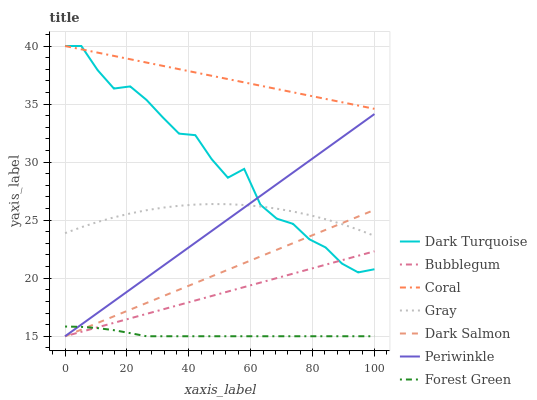Does Forest Green have the minimum area under the curve?
Answer yes or no. Yes. Does Coral have the maximum area under the curve?
Answer yes or no. Yes. Does Dark Turquoise have the minimum area under the curve?
Answer yes or no. No. Does Dark Turquoise have the maximum area under the curve?
Answer yes or no. No. Is Dark Salmon the smoothest?
Answer yes or no. Yes. Is Dark Turquoise the roughest?
Answer yes or no. Yes. Is Coral the smoothest?
Answer yes or no. No. Is Coral the roughest?
Answer yes or no. No. Does Dark Salmon have the lowest value?
Answer yes or no. Yes. Does Dark Turquoise have the lowest value?
Answer yes or no. No. Does Coral have the highest value?
Answer yes or no. Yes. Does Dark Salmon have the highest value?
Answer yes or no. No. Is Periwinkle less than Coral?
Answer yes or no. Yes. Is Dark Turquoise greater than Forest Green?
Answer yes or no. Yes. Does Gray intersect Dark Turquoise?
Answer yes or no. Yes. Is Gray less than Dark Turquoise?
Answer yes or no. No. Is Gray greater than Dark Turquoise?
Answer yes or no. No. Does Periwinkle intersect Coral?
Answer yes or no. No. 